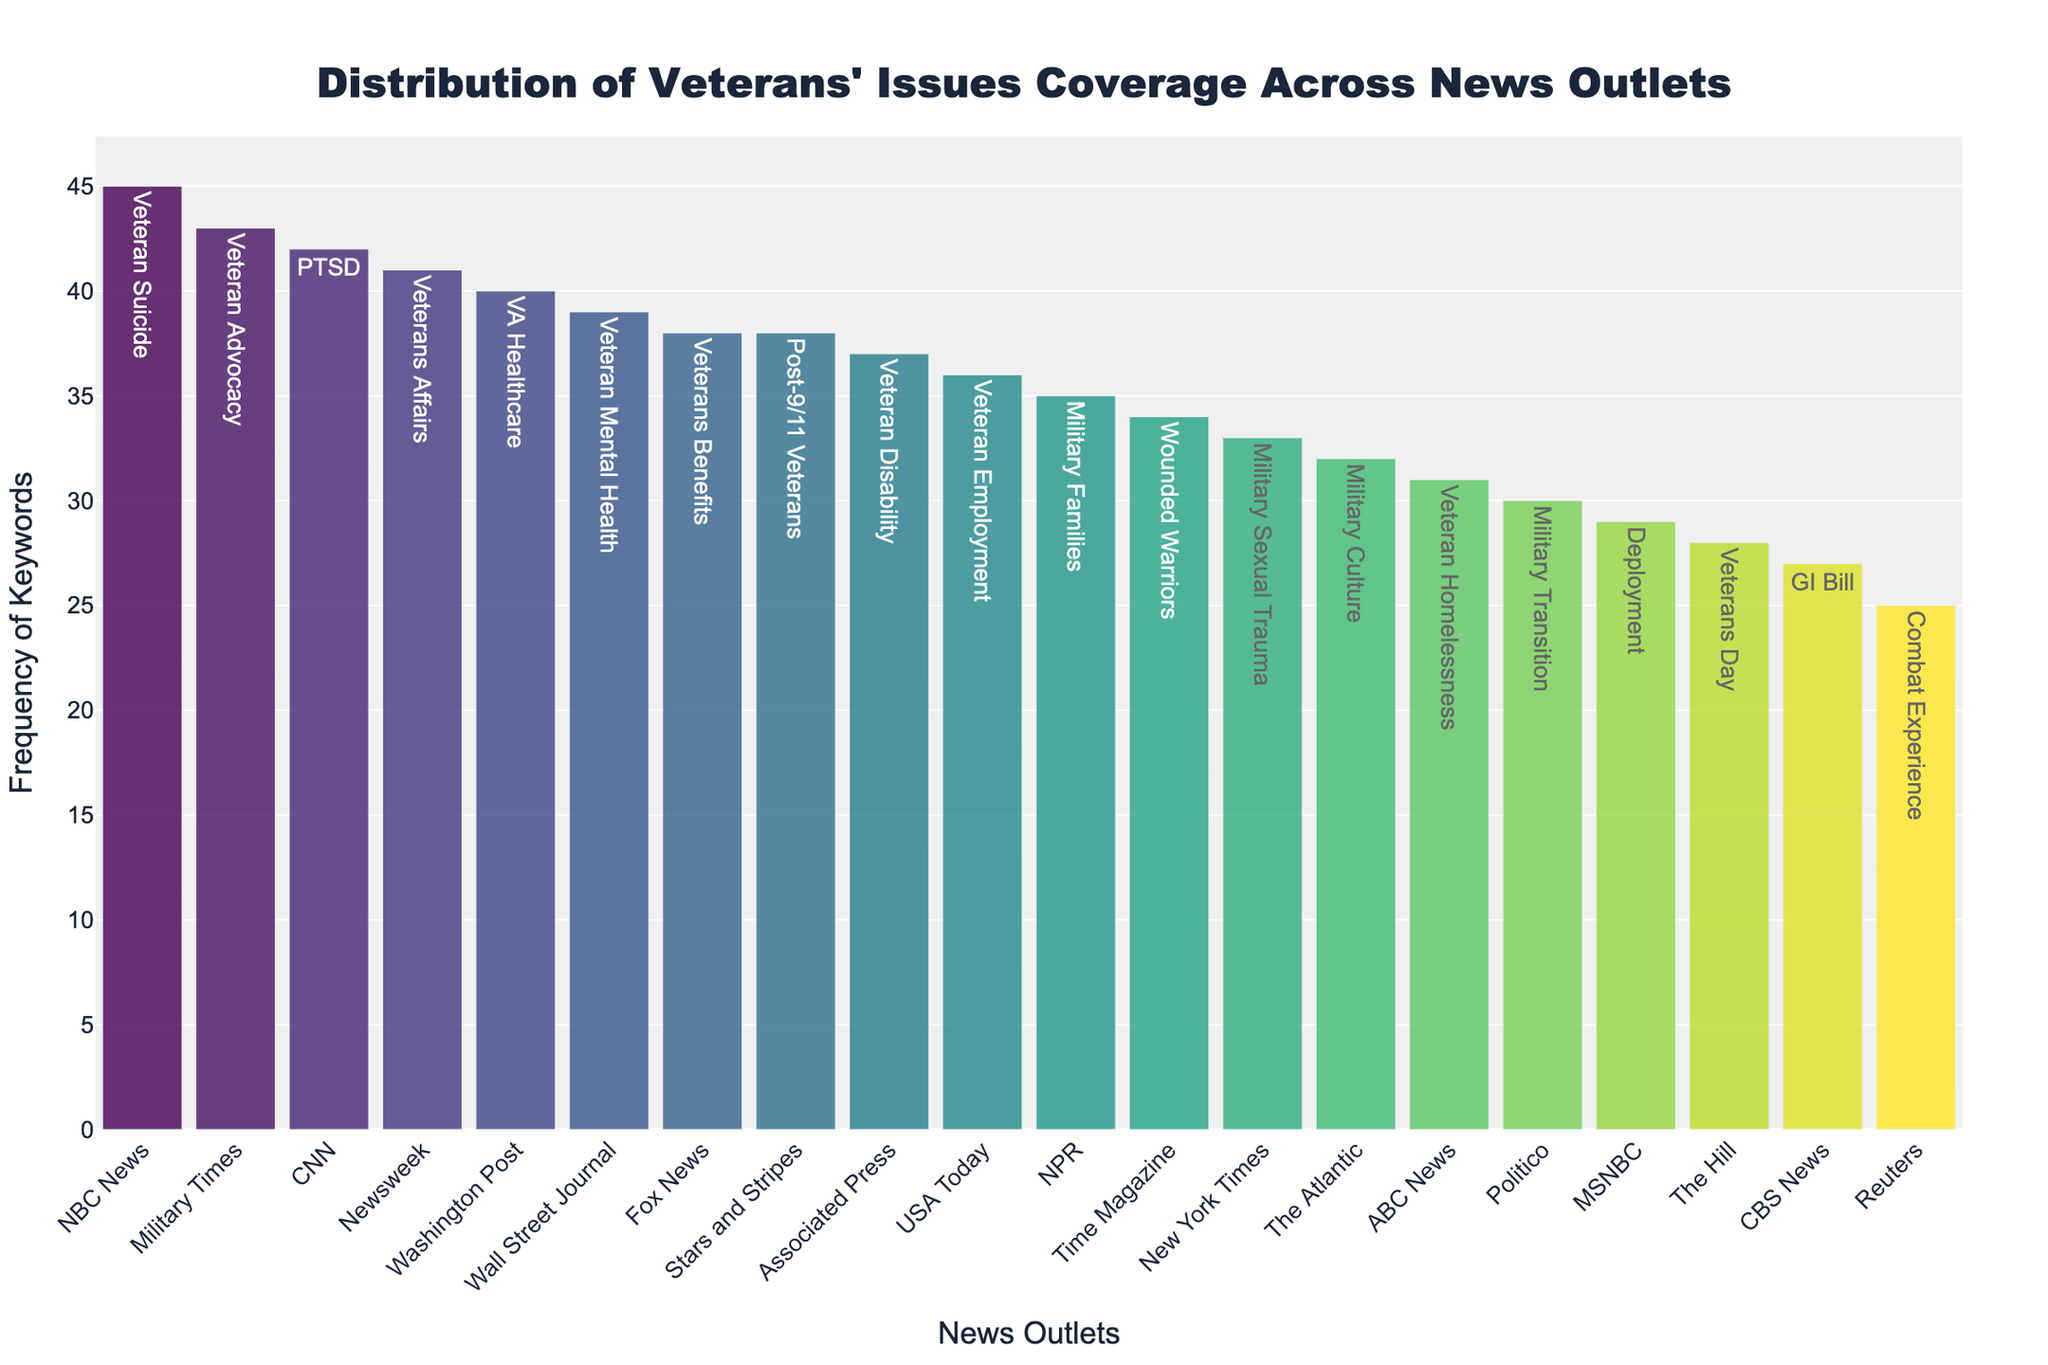What is the title of the figure? We can find the title at the top of the figure, usually in a larger font size and more prominent. The title in this case is "Distribution of Veterans' Issues Coverage Across News Outlets."
Answer: Distribution of Veterans' Issues Coverage Across News Outlets Which news outlet has the highest frequency of a keyword related to veterans' issues? By examining the heights of the bars in the figure, we can see the tallest bar indicates the highest frequency. Here, NBC News has the highest frequency with a keyword frequency of 45.
Answer: NBC News How many keywords have a frequency above 40? We need to count the number of bars whose height (frequency) is greater than 40. In the figure provided, there are three such keywords: NBC News (45), Military Times (43), and Newsweek (41).
Answer: 3 What is the total frequency of veterans' issues coverage for Fox News and Stars and Stripes combined? We need to add the frequencies of the keywords for Fox News and Stars and Stripes. Fox News has 38 and Stars and Stripes also has 38. Therefore, the combined total is 38 + 38.
Answer: 76 Which news outlet has the lowest frequency of the keyword related to veterans' issues, and what is the keyword? By finding the shortest bar in the figure, we identify Reuters as having the lowest frequency with a frequency of 25. The keyword related to this frequency is "Combat Experience".
Answer: Reuters, Combat Experience What is the median frequency of keyword coverage across all outlets? To find the median, we first list all the frequencies in numerical order and then find the middle value. The ordered frequencies are [25, 27, 28, 29, 30, 31, 32, 33, 34, 35, 36, 37, 38, 38, 39, 40, 41, 42, 43, 45]. With 20 data points, the median will be the average of the 10th and 11th values, which are 34 and 35. So, the median is (34 + 35) / 2.
Answer: 34.5 Which keyword and corresponding frequency represents The Atlantic? We look for The Atlantic's bar in the figure to find the frequency and keyword associated with it. The Atlantic has the keyword "Military Culture" with a frequency of 32.
Answer: Military Culture, 32 How much higher is the frequency of the keyword for the Washington Post compared to CBS News? We subtract the frequency of CBS News from the frequency of the Washington Post. The frequencies are Washington Post (40) and CBS News (27). Therefore, the difference is 40 - 27.
Answer: 13 